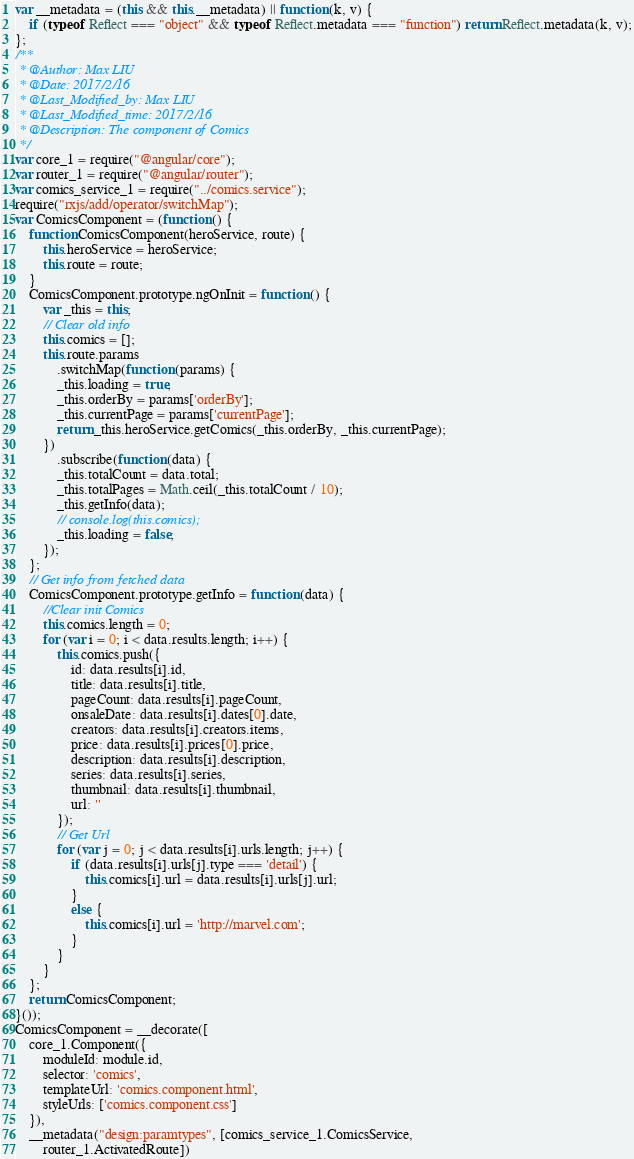Convert code to text. <code><loc_0><loc_0><loc_500><loc_500><_JavaScript_>var __metadata = (this && this.__metadata) || function (k, v) {
    if (typeof Reflect === "object" && typeof Reflect.metadata === "function") return Reflect.metadata(k, v);
};
/**
 * @Author: Max LIU
 * @Date: 2017/2/16
 * @Last_Modified_by: Max LIU
 * @Last_Modified_time: 2017/2/16
 * @Description: The component of Comics
 */
var core_1 = require("@angular/core");
var router_1 = require("@angular/router");
var comics_service_1 = require("../comics.service");
require("rxjs/add/operator/switchMap");
var ComicsComponent = (function () {
    function ComicsComponent(heroService, route) {
        this.heroService = heroService;
        this.route = route;
    }
    ComicsComponent.prototype.ngOnInit = function () {
        var _this = this;
        // Clear old info
        this.comics = [];
        this.route.params
            .switchMap(function (params) {
            _this.loading = true;
            _this.orderBy = params['orderBy'];
            _this.currentPage = params['currentPage'];
            return _this.heroService.getComics(_this.orderBy, _this.currentPage);
        })
            .subscribe(function (data) {
            _this.totalCount = data.total;
            _this.totalPages = Math.ceil(_this.totalCount / 10);
            _this.getInfo(data);
            // console.log(this.comics);
            _this.loading = false;
        });
    };
    // Get info from fetched data
    ComicsComponent.prototype.getInfo = function (data) {
        //Clear init Comics
        this.comics.length = 0;
        for (var i = 0; i < data.results.length; i++) {
            this.comics.push({
                id: data.results[i].id,
                title: data.results[i].title,
                pageCount: data.results[i].pageCount,
                onsaleDate: data.results[i].dates[0].date,
                creators: data.results[i].creators.items,
                price: data.results[i].prices[0].price,
                description: data.results[i].description,
                series: data.results[i].series,
                thumbnail: data.results[i].thumbnail,
                url: ''
            });
            // Get Url
            for (var j = 0; j < data.results[i].urls.length; j++) {
                if (data.results[i].urls[j].type === 'detail') {
                    this.comics[i].url = data.results[i].urls[j].url;
                }
                else {
                    this.comics[i].url = 'http://marvel.com';
                }
            }
        }
    };
    return ComicsComponent;
}());
ComicsComponent = __decorate([
    core_1.Component({
        moduleId: module.id,
        selector: 'comics',
        templateUrl: 'comics.component.html',
        styleUrls: ['comics.component.css']
    }),
    __metadata("design:paramtypes", [comics_service_1.ComicsService,
        router_1.ActivatedRoute])</code> 